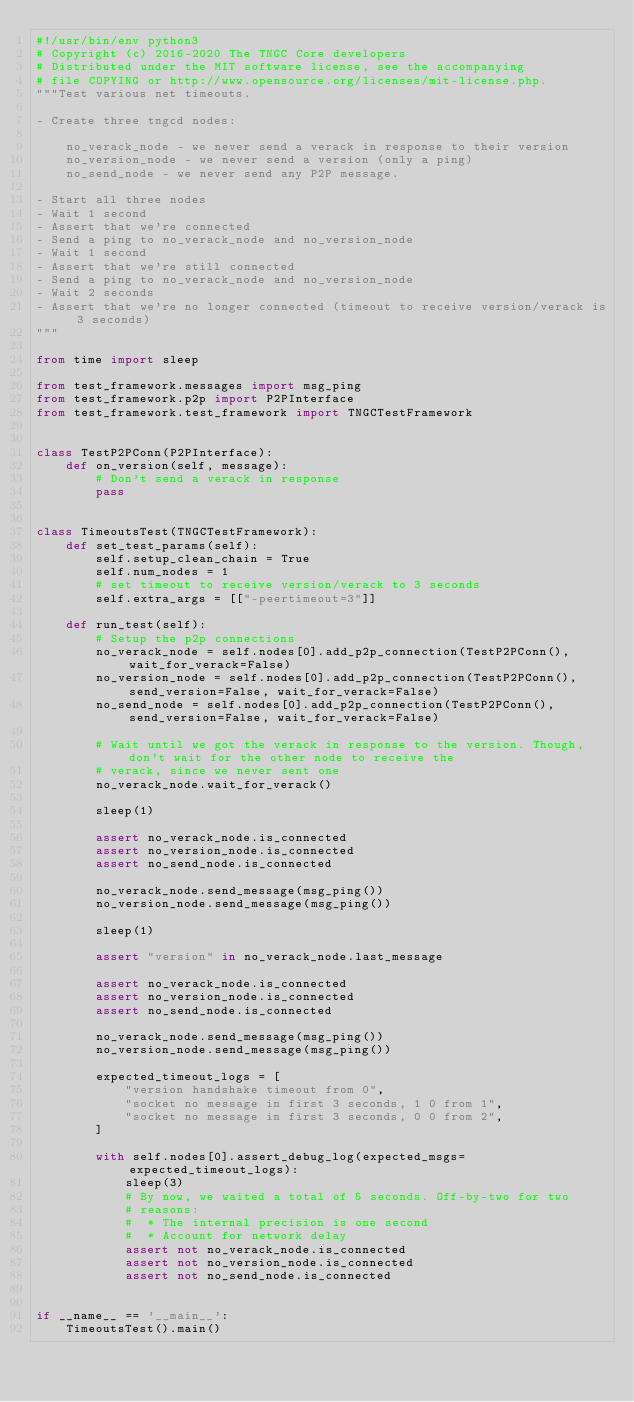Convert code to text. <code><loc_0><loc_0><loc_500><loc_500><_Python_>#!/usr/bin/env python3
# Copyright (c) 2016-2020 The TNGC Core developers
# Distributed under the MIT software license, see the accompanying
# file COPYING or http://www.opensource.org/licenses/mit-license.php.
"""Test various net timeouts.

- Create three tngcd nodes:

    no_verack_node - we never send a verack in response to their version
    no_version_node - we never send a version (only a ping)
    no_send_node - we never send any P2P message.

- Start all three nodes
- Wait 1 second
- Assert that we're connected
- Send a ping to no_verack_node and no_version_node
- Wait 1 second
- Assert that we're still connected
- Send a ping to no_verack_node and no_version_node
- Wait 2 seconds
- Assert that we're no longer connected (timeout to receive version/verack is 3 seconds)
"""

from time import sleep

from test_framework.messages import msg_ping
from test_framework.p2p import P2PInterface
from test_framework.test_framework import TNGCTestFramework


class TestP2PConn(P2PInterface):
    def on_version(self, message):
        # Don't send a verack in response
        pass


class TimeoutsTest(TNGCTestFramework):
    def set_test_params(self):
        self.setup_clean_chain = True
        self.num_nodes = 1
        # set timeout to receive version/verack to 3 seconds
        self.extra_args = [["-peertimeout=3"]]

    def run_test(self):
        # Setup the p2p connections
        no_verack_node = self.nodes[0].add_p2p_connection(TestP2PConn(), wait_for_verack=False)
        no_version_node = self.nodes[0].add_p2p_connection(TestP2PConn(), send_version=False, wait_for_verack=False)
        no_send_node = self.nodes[0].add_p2p_connection(TestP2PConn(), send_version=False, wait_for_verack=False)

        # Wait until we got the verack in response to the version. Though, don't wait for the other node to receive the
        # verack, since we never sent one
        no_verack_node.wait_for_verack()

        sleep(1)

        assert no_verack_node.is_connected
        assert no_version_node.is_connected
        assert no_send_node.is_connected

        no_verack_node.send_message(msg_ping())
        no_version_node.send_message(msg_ping())

        sleep(1)

        assert "version" in no_verack_node.last_message

        assert no_verack_node.is_connected
        assert no_version_node.is_connected
        assert no_send_node.is_connected

        no_verack_node.send_message(msg_ping())
        no_version_node.send_message(msg_ping())

        expected_timeout_logs = [
            "version handshake timeout from 0",
            "socket no message in first 3 seconds, 1 0 from 1",
            "socket no message in first 3 seconds, 0 0 from 2",
        ]

        with self.nodes[0].assert_debug_log(expected_msgs=expected_timeout_logs):
            sleep(3)
            # By now, we waited a total of 5 seconds. Off-by-two for two
            # reasons:
            #  * The internal precision is one second
            #  * Account for network delay
            assert not no_verack_node.is_connected
            assert not no_version_node.is_connected
            assert not no_send_node.is_connected


if __name__ == '__main__':
    TimeoutsTest().main()
</code> 